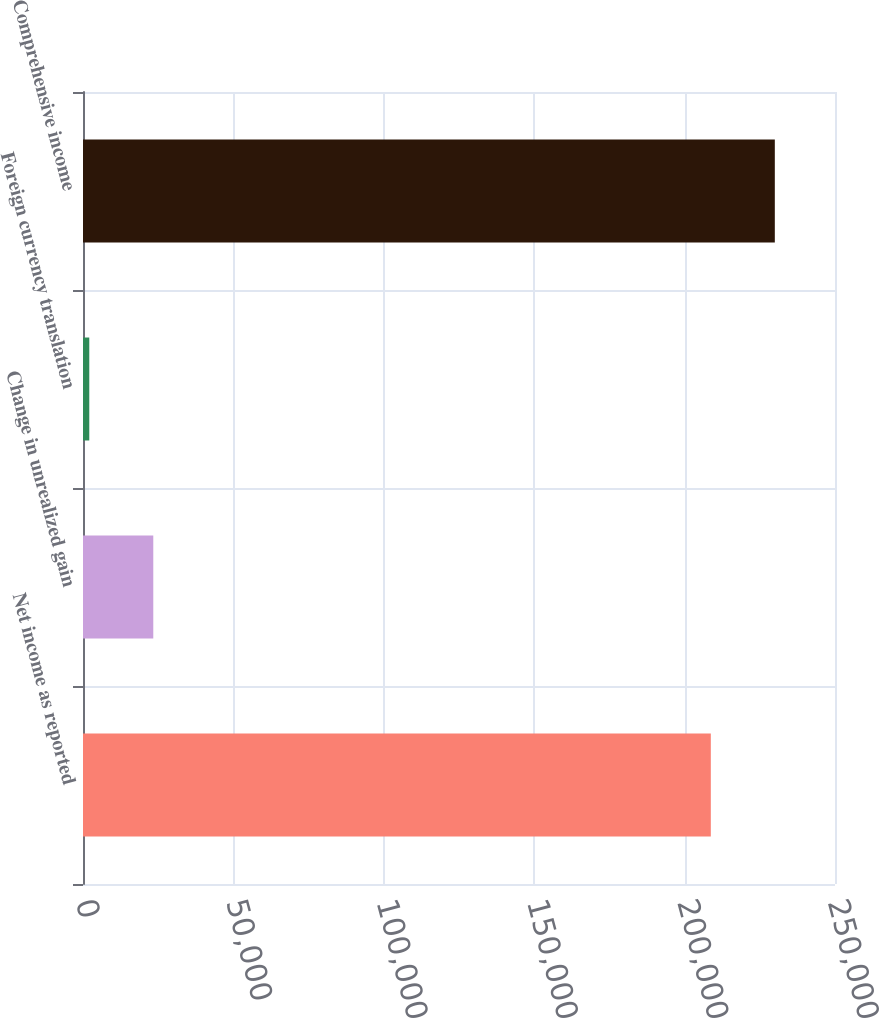Convert chart to OTSL. <chart><loc_0><loc_0><loc_500><loc_500><bar_chart><fcel>Net income as reported<fcel>Change in unrealized gain<fcel>Foreign currency translation<fcel>Comprehensive income<nl><fcel>208716<fcel>23365.7<fcel>2087<fcel>229995<nl></chart> 